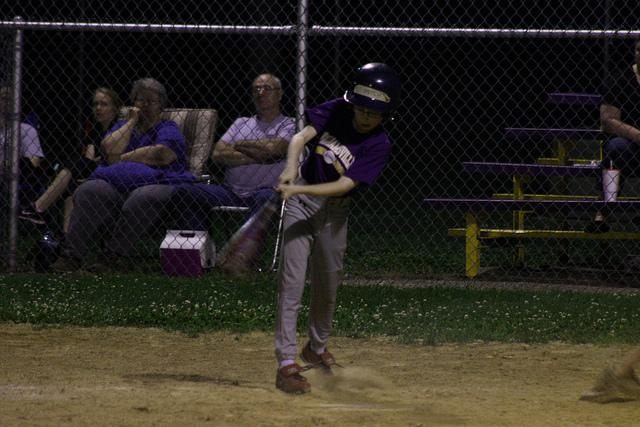If the boy is unsuccessful in doing what he is doing three times in a row what is it called? strike out 